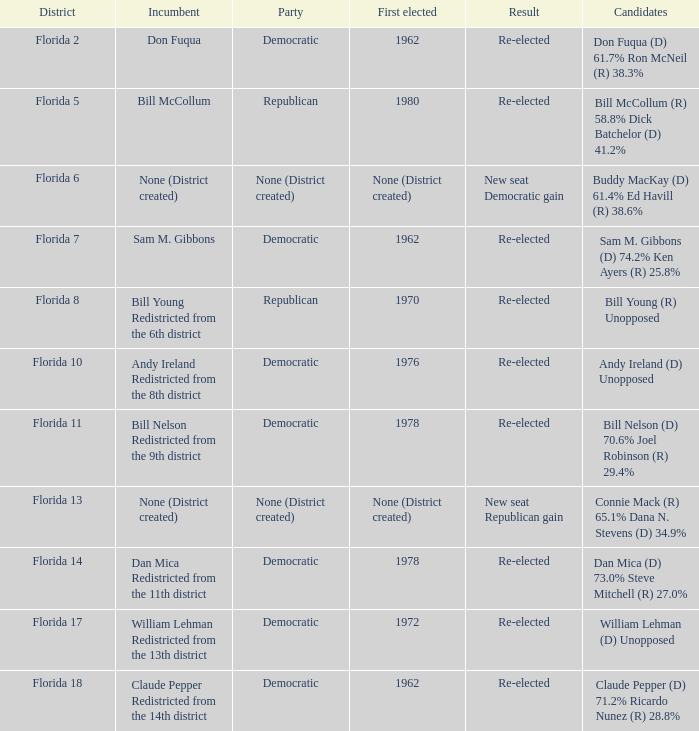 how many result with district being florida 14 1.0. 